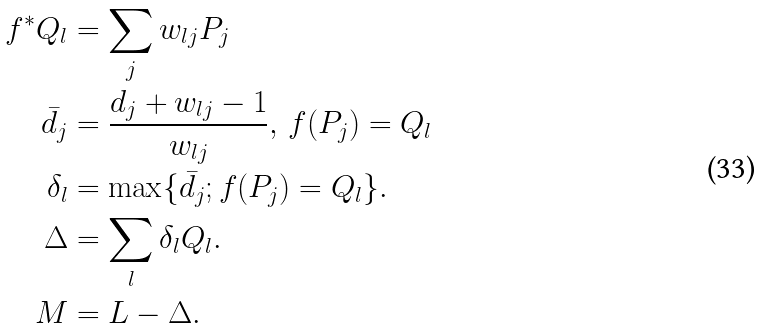Convert formula to latex. <formula><loc_0><loc_0><loc_500><loc_500>f ^ { * } Q _ { l } & = \sum _ { j } w _ { l j } P _ { j } \\ \bar { d _ { j } } & = \frac { d _ { j } + w _ { l j } - 1 } { w _ { l j } } , \, f ( P _ { j } ) = Q _ { l } \\ \delta _ { l } & = \max \{ \bar { d _ { j } } ; f ( P _ { j } ) = Q _ { l } \} . \\ \Delta & = \sum _ { l } \delta _ { l } Q _ { l } . \\ M & = L - \Delta . \\</formula> 